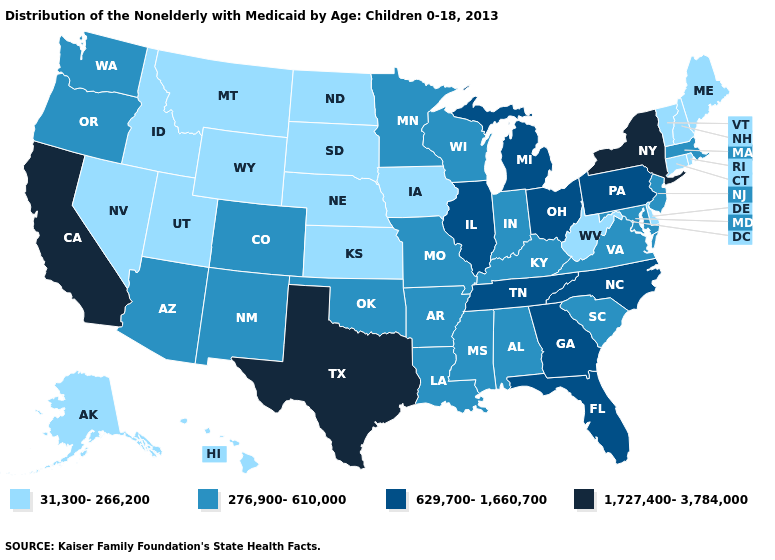Which states have the lowest value in the USA?
Write a very short answer. Alaska, Connecticut, Delaware, Hawaii, Idaho, Iowa, Kansas, Maine, Montana, Nebraska, Nevada, New Hampshire, North Dakota, Rhode Island, South Dakota, Utah, Vermont, West Virginia, Wyoming. What is the lowest value in the South?
Concise answer only. 31,300-266,200. Does Colorado have the lowest value in the West?
Write a very short answer. No. Name the states that have a value in the range 1,727,400-3,784,000?
Concise answer only. California, New York, Texas. Does the first symbol in the legend represent the smallest category?
Write a very short answer. Yes. Does New York have the same value as California?
Answer briefly. Yes. Name the states that have a value in the range 1,727,400-3,784,000?
Keep it brief. California, New York, Texas. Does the map have missing data?
Write a very short answer. No. Name the states that have a value in the range 31,300-266,200?
Short answer required. Alaska, Connecticut, Delaware, Hawaii, Idaho, Iowa, Kansas, Maine, Montana, Nebraska, Nevada, New Hampshire, North Dakota, Rhode Island, South Dakota, Utah, Vermont, West Virginia, Wyoming. What is the value of Iowa?
Answer briefly. 31,300-266,200. What is the highest value in the USA?
Write a very short answer. 1,727,400-3,784,000. Which states have the highest value in the USA?
Write a very short answer. California, New York, Texas. Does the first symbol in the legend represent the smallest category?
Keep it brief. Yes. Which states have the lowest value in the USA?
Give a very brief answer. Alaska, Connecticut, Delaware, Hawaii, Idaho, Iowa, Kansas, Maine, Montana, Nebraska, Nevada, New Hampshire, North Dakota, Rhode Island, South Dakota, Utah, Vermont, West Virginia, Wyoming. What is the lowest value in the USA?
Concise answer only. 31,300-266,200. 